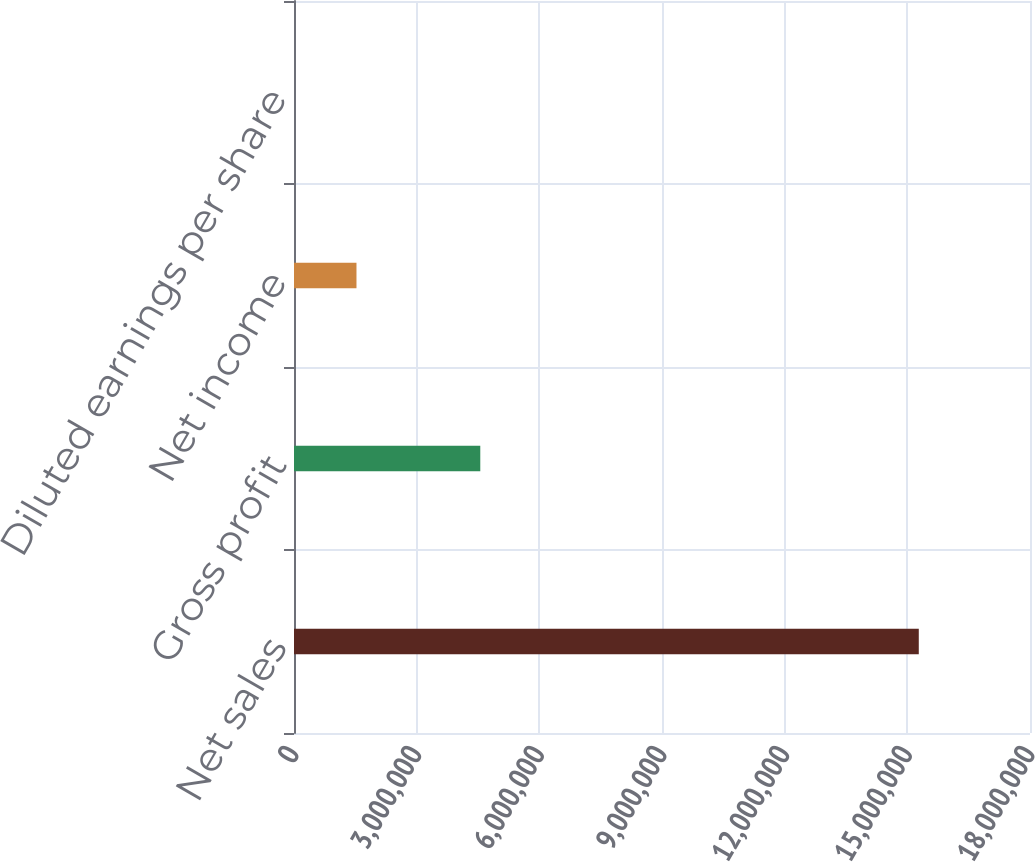Convert chart to OTSL. <chart><loc_0><loc_0><loc_500><loc_500><bar_chart><fcel>Net sales<fcel>Gross profit<fcel>Net income<fcel>Diluted earnings per share<nl><fcel>1.528e+07<fcel>4.55585e+06<fcel>1.52801e+06<fcel>4.63<nl></chart> 